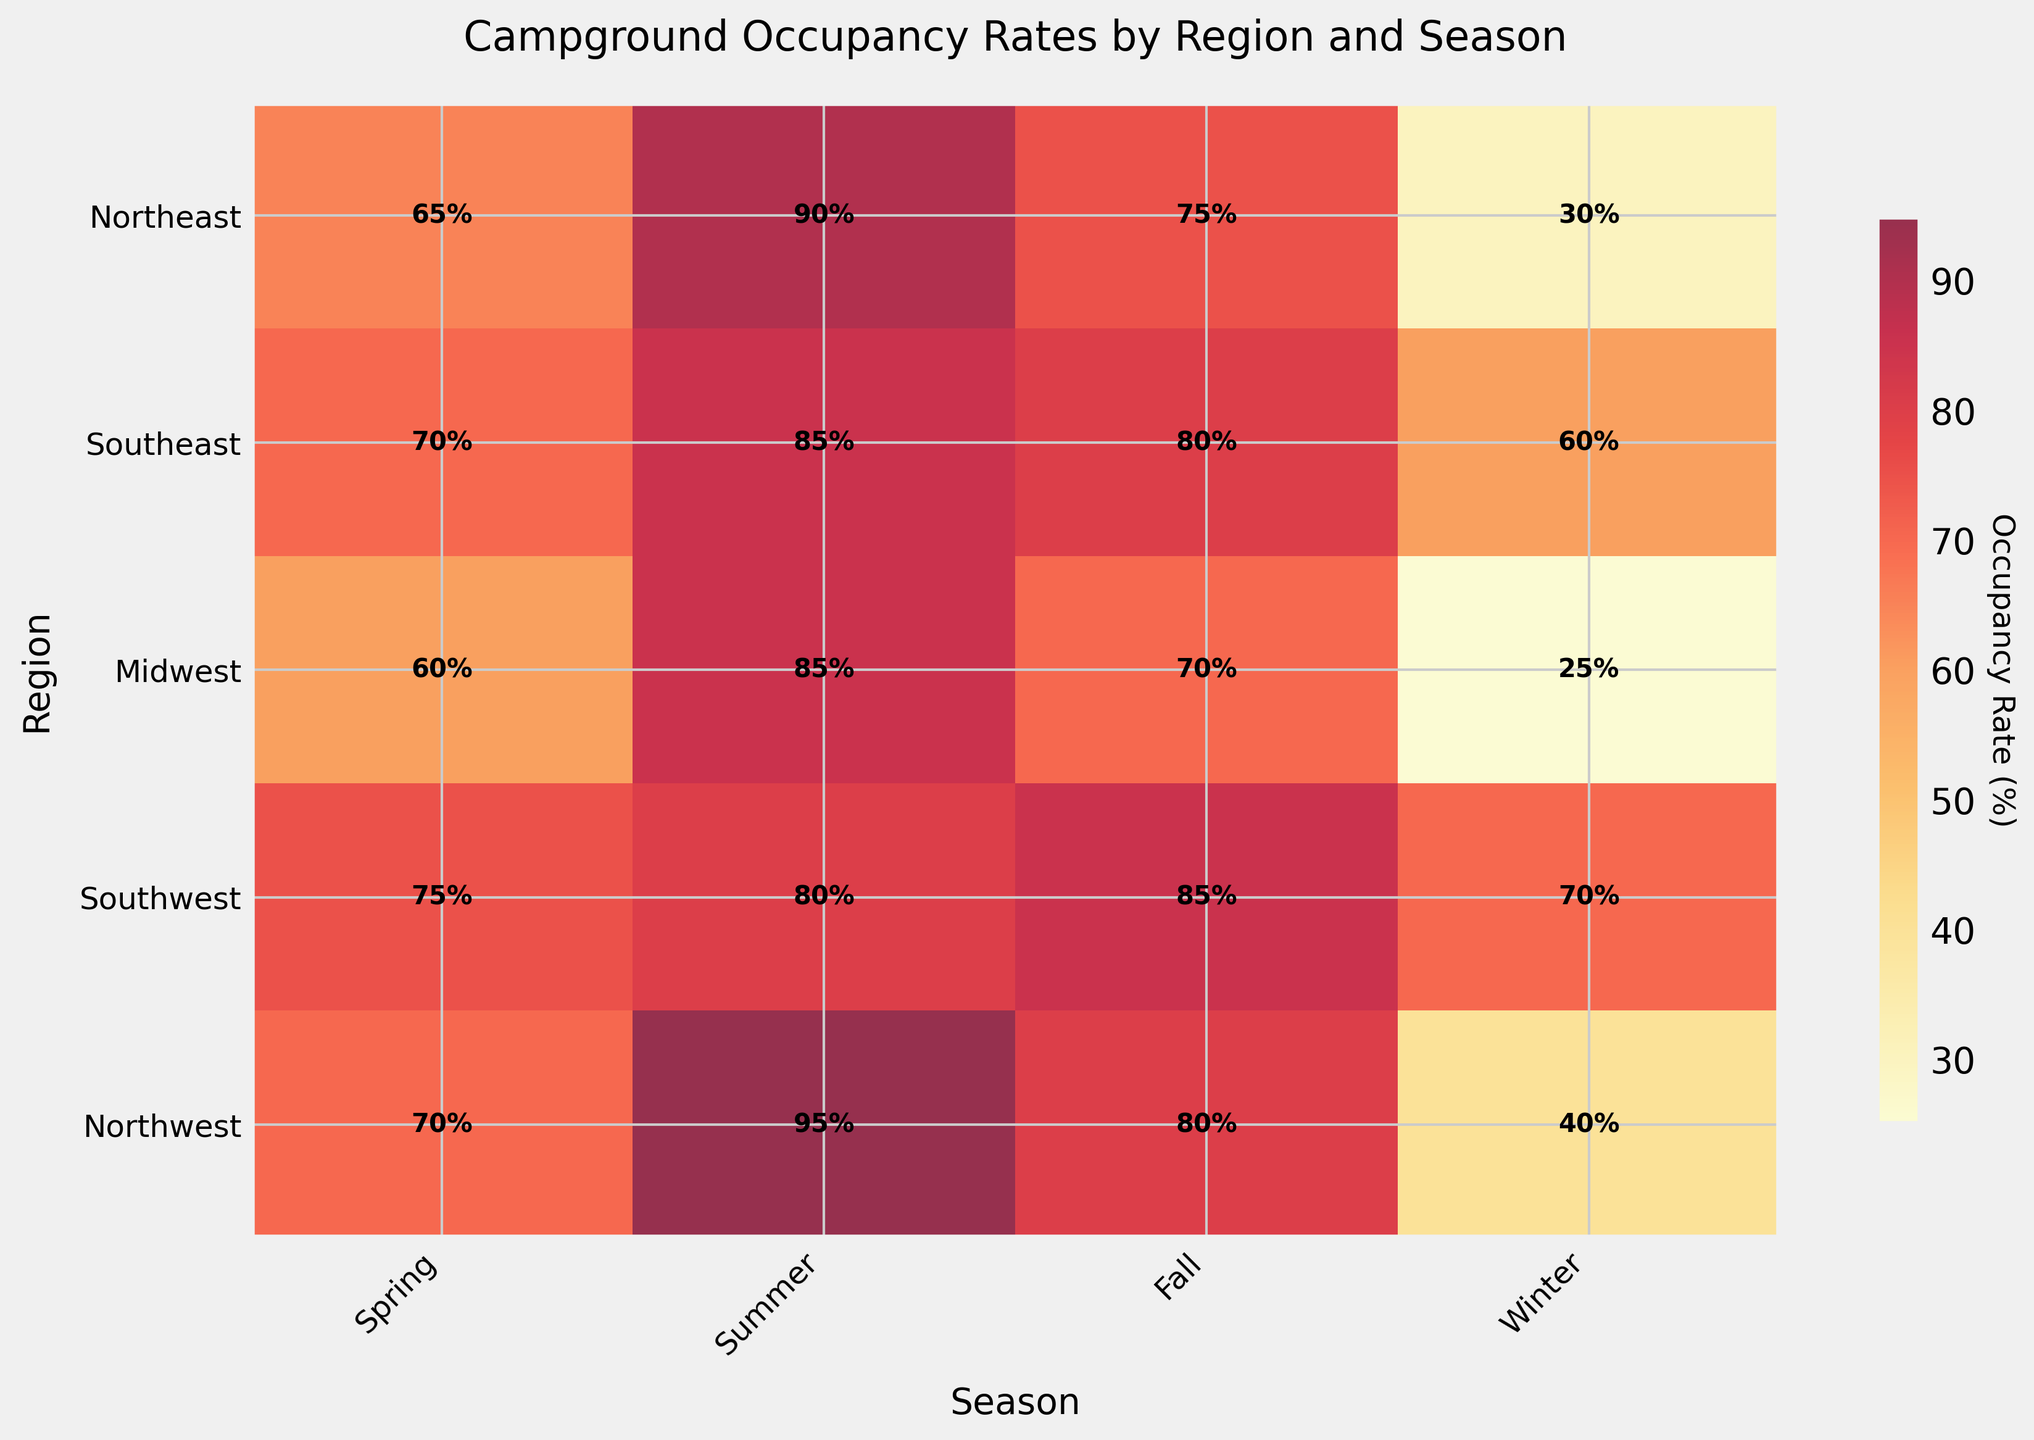What is the title of the figure? The title of the figure is displayed at the top of the plot and summarizes what the plot is about.
Answer: Campground Occupancy Rates by Region and Season Which season shows the highest occupancy rate in the Northeast? Look at the row corresponding to the Northeast region and identify the season with the highest percentage.
Answer: Summer Which region has the lowest occupancy rate in Winter? Look at the Winter column and identify the region with the lowest occupancy percentage.
Answer: Midwest What is the average occupancy rate for the Southeast region? Sum the occupancy rates for the Southeast region across all seasons and divide by the number of seasons. Calculation: (70 + 85 + 80 + 60) / 4 = 73.75
Answer: 73.75% Is the occupancy rate in the Midwest in Fall greater than in Spring? Compare the occupancy rates for the Midwest region in the Fall (70%) and in the Spring (60%).
Answer: Yes Which season shows the greatest variation in occupancy rates across different regions? Compare the range (difference between maximum and minimum values) of occupancy rates across all regions for each season. Calculation for each season shows that Winter has the greatest variation: 70% - 25% = 45%.
Answer: Winter How does the occupancy rate in the Northwest during Winter compare to the Southwest during Winter? Compare the numbers for the Northwest (40%) and the Southwest (70%) during Winter.
Answer: Northwest has a lower occupancy Which region generally has the highest occupancy rates across all seasons? Calculate the average occupancy rate for each region: 
Northeast: (65 + 90 + 75 + 30) / 4 = 65% 
Southeast: (70 + 85 + 80 + 60) / 4 = 73.75% 
Midwest: (60 + 85 + 70 + 25) / 4 = 60% 
Southwest: (75 + 80 + 85 + 70) / 4 = 77.5% 
Northwest: (70 + 95 + 80 + 40) / 4 = 71.25%. 
The Southwest has the highest average occupancy rate.
Answer: Southwest What is the difference in occupancy rate between Fall and Winter in the Northeast? Subtract the Winter occupancy rate in the Northeast (30%) from the Fall occupancy rate (75%).
Answer: 45% 